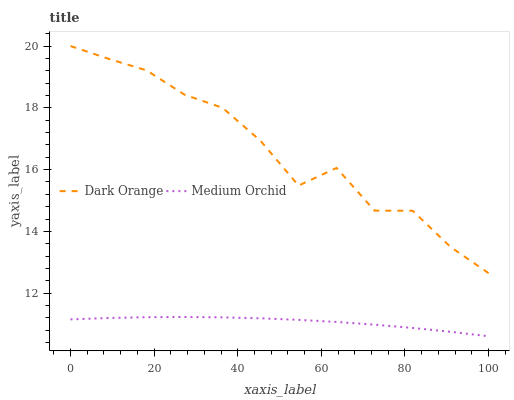Does Medium Orchid have the minimum area under the curve?
Answer yes or no. Yes. Does Dark Orange have the maximum area under the curve?
Answer yes or no. Yes. Does Medium Orchid have the maximum area under the curve?
Answer yes or no. No. Is Medium Orchid the smoothest?
Answer yes or no. Yes. Is Dark Orange the roughest?
Answer yes or no. Yes. Is Medium Orchid the roughest?
Answer yes or no. No. Does Medium Orchid have the lowest value?
Answer yes or no. Yes. Does Dark Orange have the highest value?
Answer yes or no. Yes. Does Medium Orchid have the highest value?
Answer yes or no. No. Is Medium Orchid less than Dark Orange?
Answer yes or no. Yes. Is Dark Orange greater than Medium Orchid?
Answer yes or no. Yes. Does Medium Orchid intersect Dark Orange?
Answer yes or no. No. 